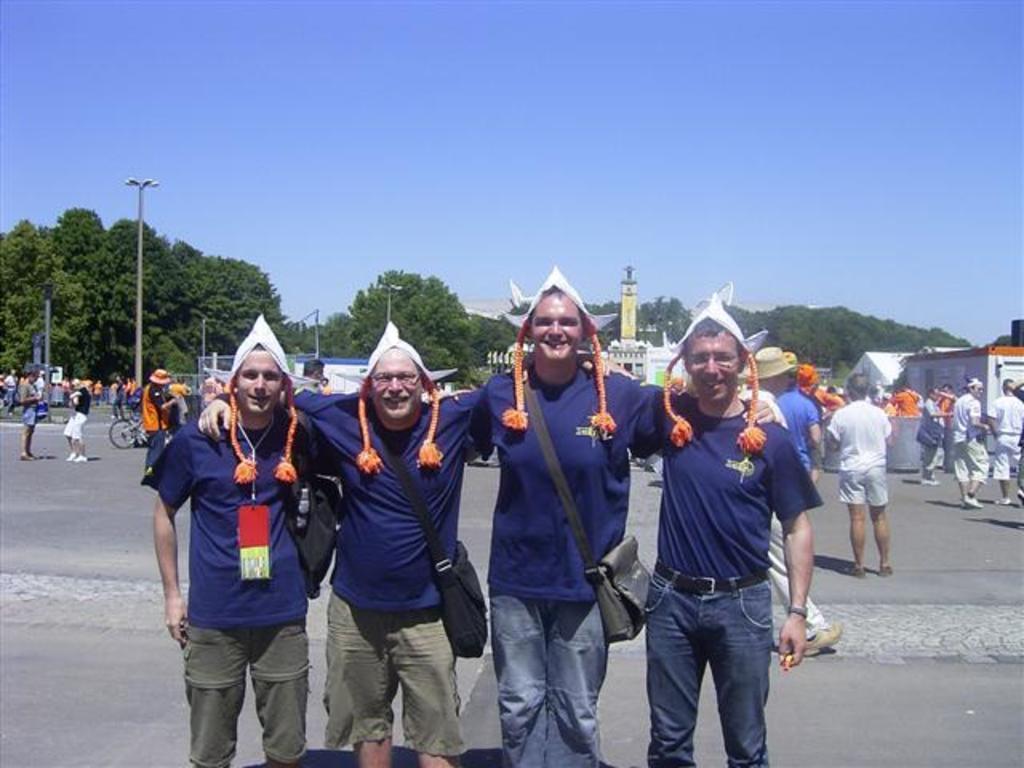In one or two sentences, can you explain what this image depicts? In this picture we can see four men smiling, standing on the road and at the back of them we can see a group of people, bicycle, poles, trees, buildings, some objects and in the background we can see the sky. 